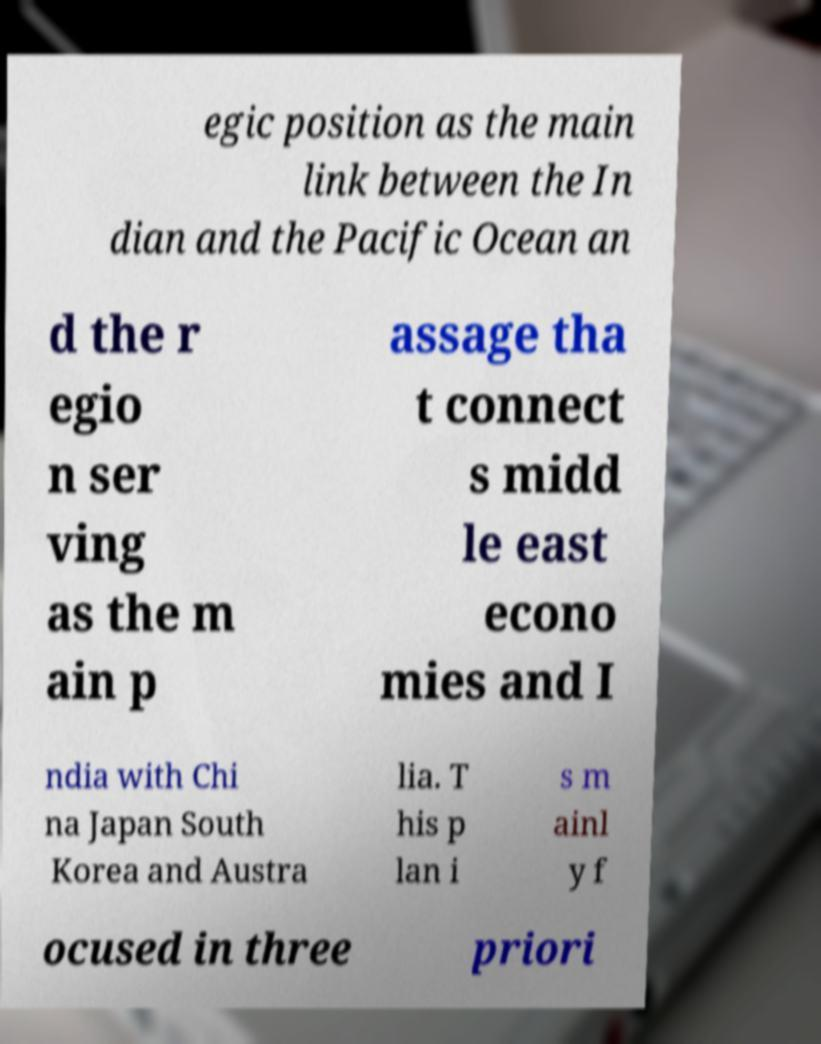I need the written content from this picture converted into text. Can you do that? egic position as the main link between the In dian and the Pacific Ocean an d the r egio n ser ving as the m ain p assage tha t connect s midd le east econo mies and I ndia with Chi na Japan South Korea and Austra lia. T his p lan i s m ainl y f ocused in three priori 